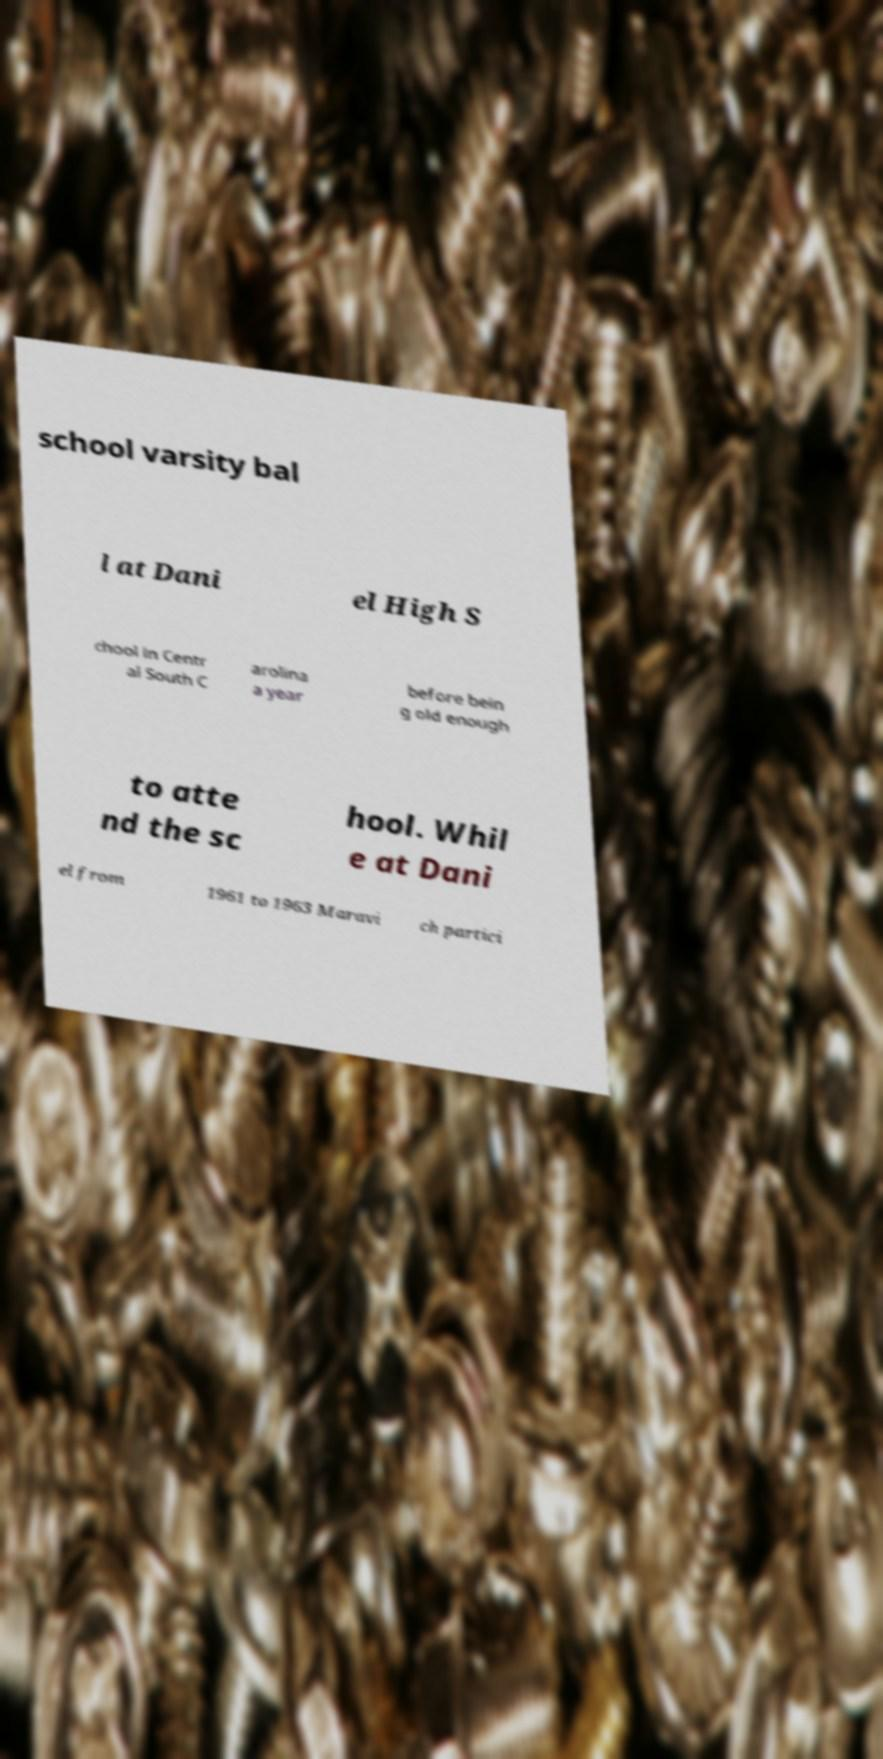There's text embedded in this image that I need extracted. Can you transcribe it verbatim? school varsity bal l at Dani el High S chool in Centr al South C arolina a year before bein g old enough to atte nd the sc hool. Whil e at Dani el from 1961 to 1963 Maravi ch partici 